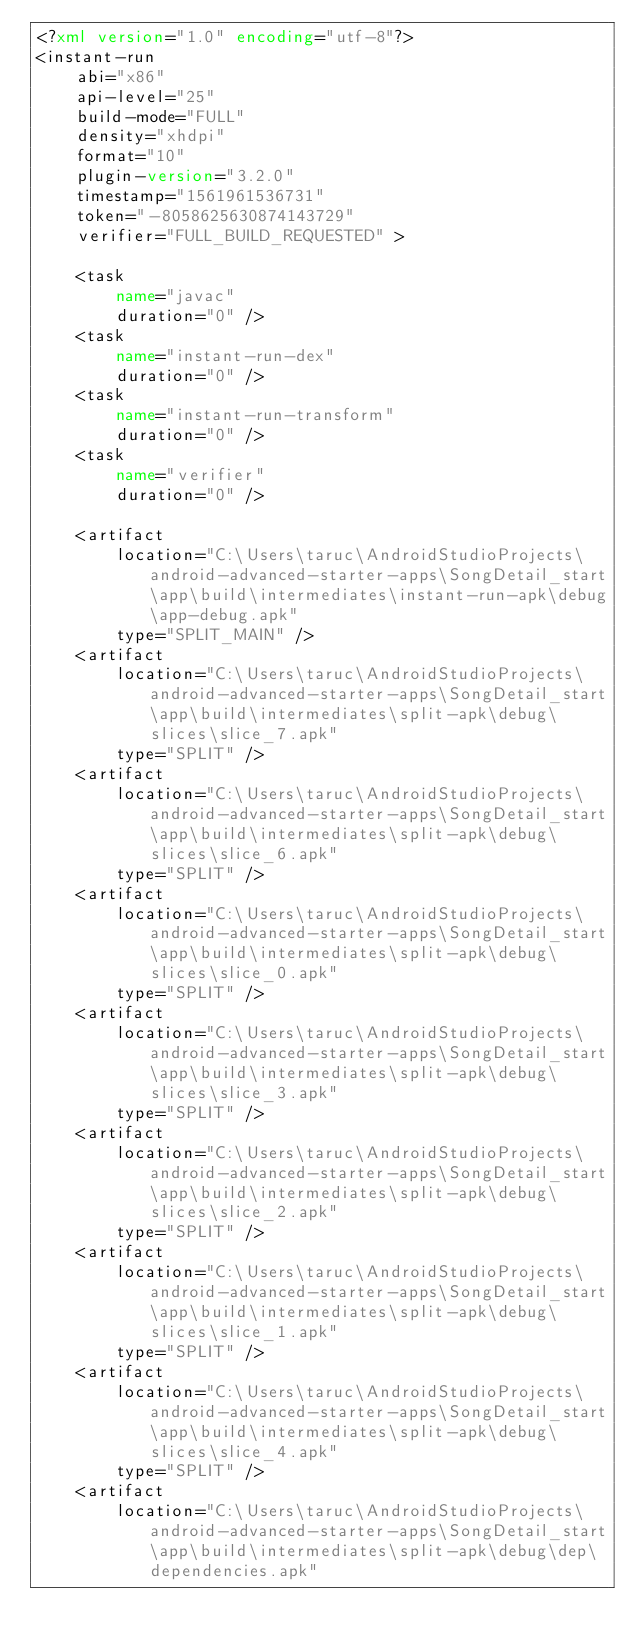<code> <loc_0><loc_0><loc_500><loc_500><_XML_><?xml version="1.0" encoding="utf-8"?>
<instant-run
    abi="x86"
    api-level="25"
    build-mode="FULL"
    density="xhdpi"
    format="10"
    plugin-version="3.2.0"
    timestamp="1561961536731"
    token="-8058625630874143729"
    verifier="FULL_BUILD_REQUESTED" >

    <task
        name="javac"
        duration="0" />
    <task
        name="instant-run-dex"
        duration="0" />
    <task
        name="instant-run-transform"
        duration="0" />
    <task
        name="verifier"
        duration="0" />

    <artifact
        location="C:\Users\taruc\AndroidStudioProjects\android-advanced-starter-apps\SongDetail_start\app\build\intermediates\instant-run-apk\debug\app-debug.apk"
        type="SPLIT_MAIN" />
    <artifact
        location="C:\Users\taruc\AndroidStudioProjects\android-advanced-starter-apps\SongDetail_start\app\build\intermediates\split-apk\debug\slices\slice_7.apk"
        type="SPLIT" />
    <artifact
        location="C:\Users\taruc\AndroidStudioProjects\android-advanced-starter-apps\SongDetail_start\app\build\intermediates\split-apk\debug\slices\slice_6.apk"
        type="SPLIT" />
    <artifact
        location="C:\Users\taruc\AndroidStudioProjects\android-advanced-starter-apps\SongDetail_start\app\build\intermediates\split-apk\debug\slices\slice_0.apk"
        type="SPLIT" />
    <artifact
        location="C:\Users\taruc\AndroidStudioProjects\android-advanced-starter-apps\SongDetail_start\app\build\intermediates\split-apk\debug\slices\slice_3.apk"
        type="SPLIT" />
    <artifact
        location="C:\Users\taruc\AndroidStudioProjects\android-advanced-starter-apps\SongDetail_start\app\build\intermediates\split-apk\debug\slices\slice_2.apk"
        type="SPLIT" />
    <artifact
        location="C:\Users\taruc\AndroidStudioProjects\android-advanced-starter-apps\SongDetail_start\app\build\intermediates\split-apk\debug\slices\slice_1.apk"
        type="SPLIT" />
    <artifact
        location="C:\Users\taruc\AndroidStudioProjects\android-advanced-starter-apps\SongDetail_start\app\build\intermediates\split-apk\debug\slices\slice_4.apk"
        type="SPLIT" />
    <artifact
        location="C:\Users\taruc\AndroidStudioProjects\android-advanced-starter-apps\SongDetail_start\app\build\intermediates\split-apk\debug\dep\dependencies.apk"</code> 